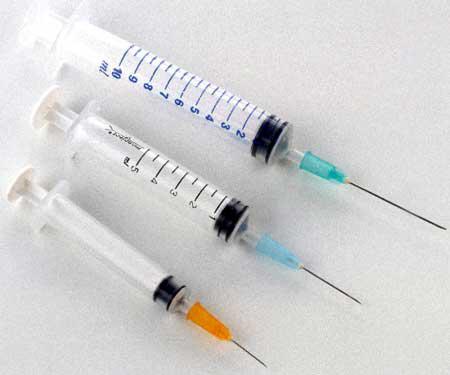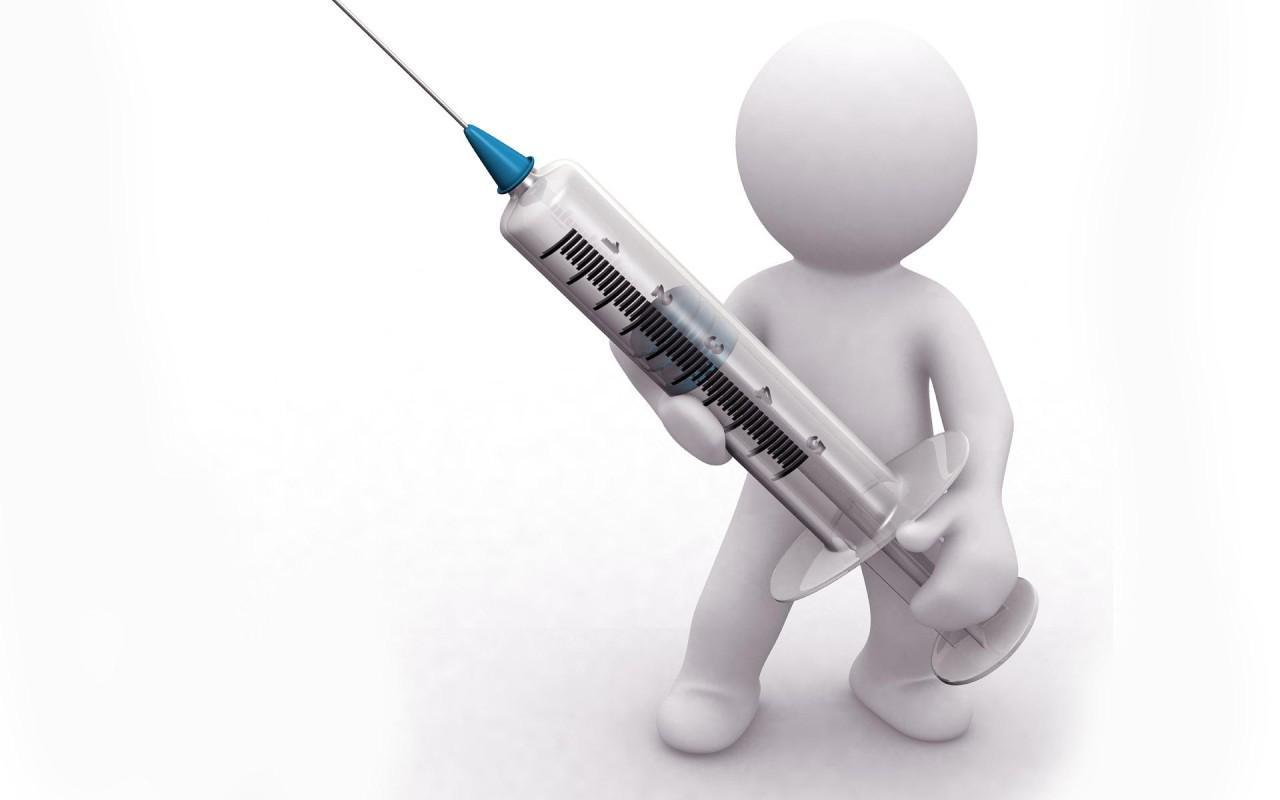The first image is the image on the left, the second image is the image on the right. Analyze the images presented: Is the assertion "One is pointing up to the right, and the other down to the left." valid? Answer yes or no. No. 